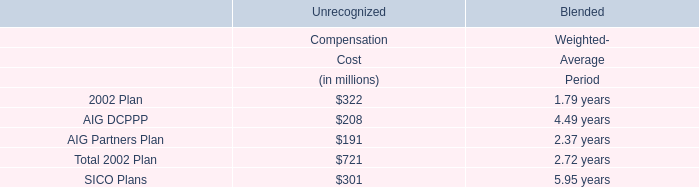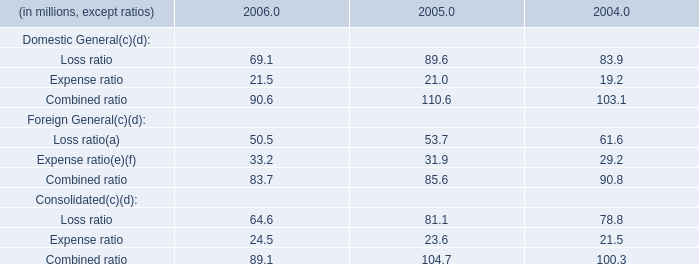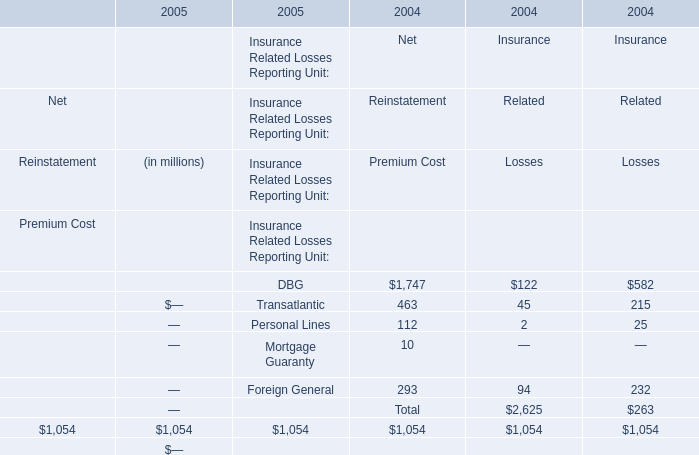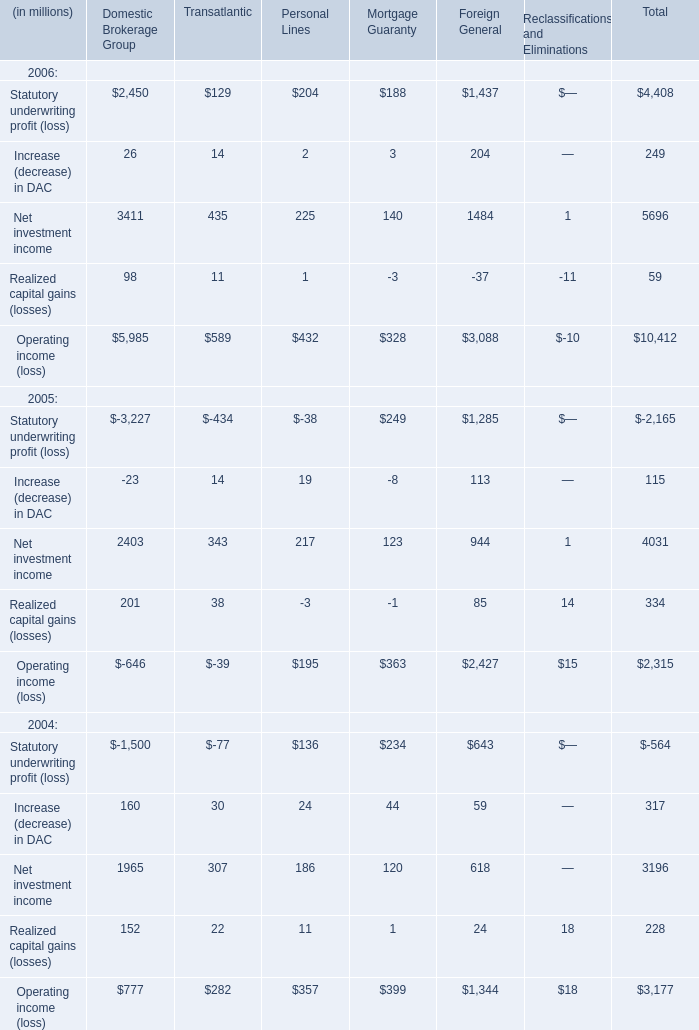If Statutory underwriting profit develops with the same growth rate in 2006, what will it reach in 2007? (in million) 
Computations: ((1 + ((4408 - -2165) / 2165)) * 4408)
Answer: 17790.81016. 